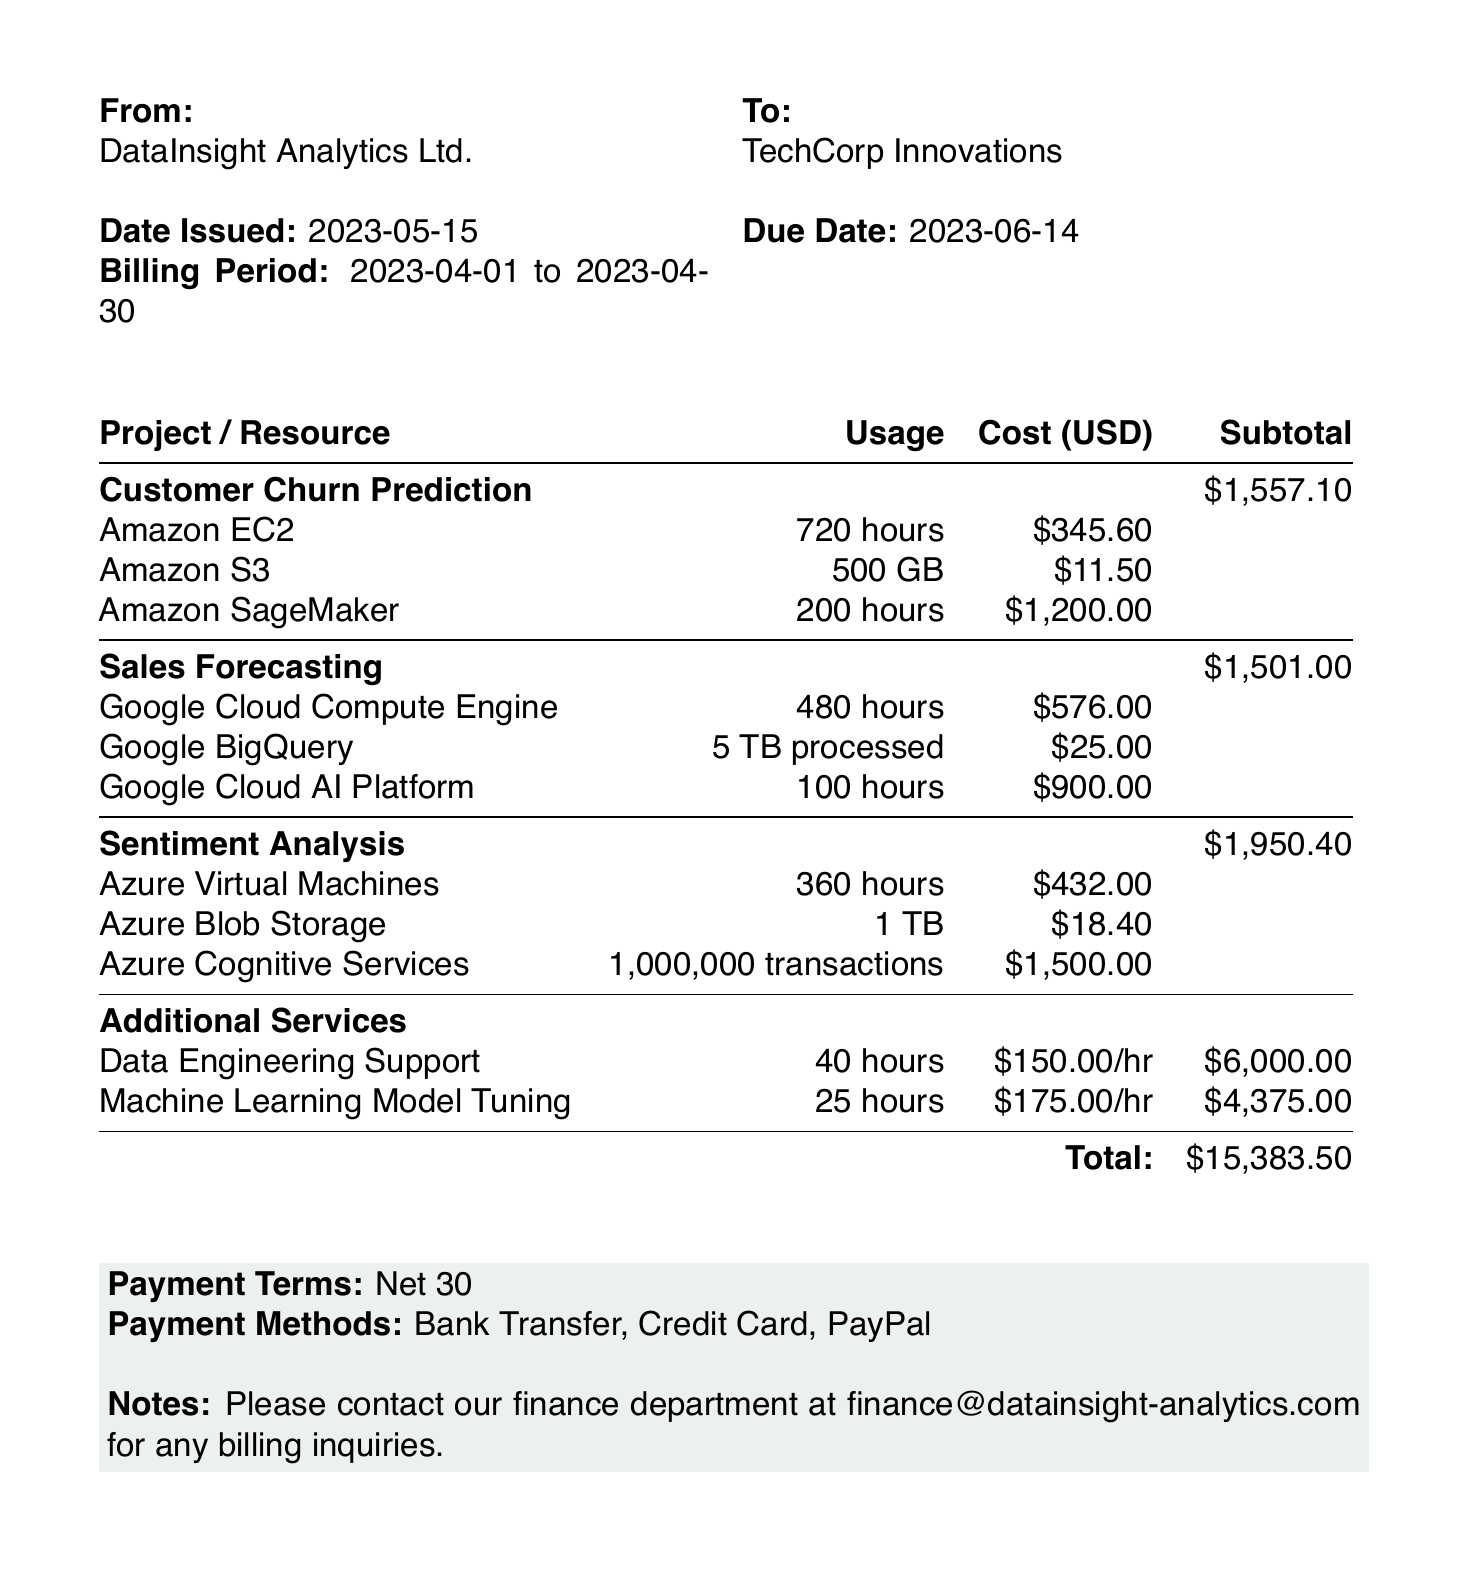what is the invoice number? The invoice number is listed at the top of the document as INV-2023-05-001.
Answer: INV-2023-05-001 who is the client? The client name is mentioned in the document as TechCorp Innovations.
Answer: TechCorp Innovations what is the billing period? The billing period indicates the time frame for the services rendered and is specified as 2023-04-01 to 2023-04-30.
Answer: 2023-04-01 to 2023-04-30 how much did Customer Churn Prediction cost? The cost for the Customer Churn Prediction project, as listed, totals to $1,557.10.
Answer: $1,557.10 what is the total amount due? The total amount due is stated in the document, which sums all charges to $15,383.50.
Answer: $15,383.50 what is the payment term? The payment terms are noted at the bottom of the invoice as Net 30.
Answer: Net 30 how many hours of Data Engineering Support were provided? The document specifies that 40 hours of Data Engineering Support were provided.
Answer: 40 hours which payment methods are accepted? The document lists the acceptable payment methods as Bank Transfer, Credit Card, and PayPal.
Answer: Bank Transfer, Credit Card, PayPal what is the subtotal for the Sentiment Analysis project? The subtotal for the Sentiment Analysis project is indicated as $1,950.40 in the breakdown.
Answer: $1,950.40 